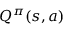<formula> <loc_0><loc_0><loc_500><loc_500>Q ^ { \pi } ( s , a )</formula> 